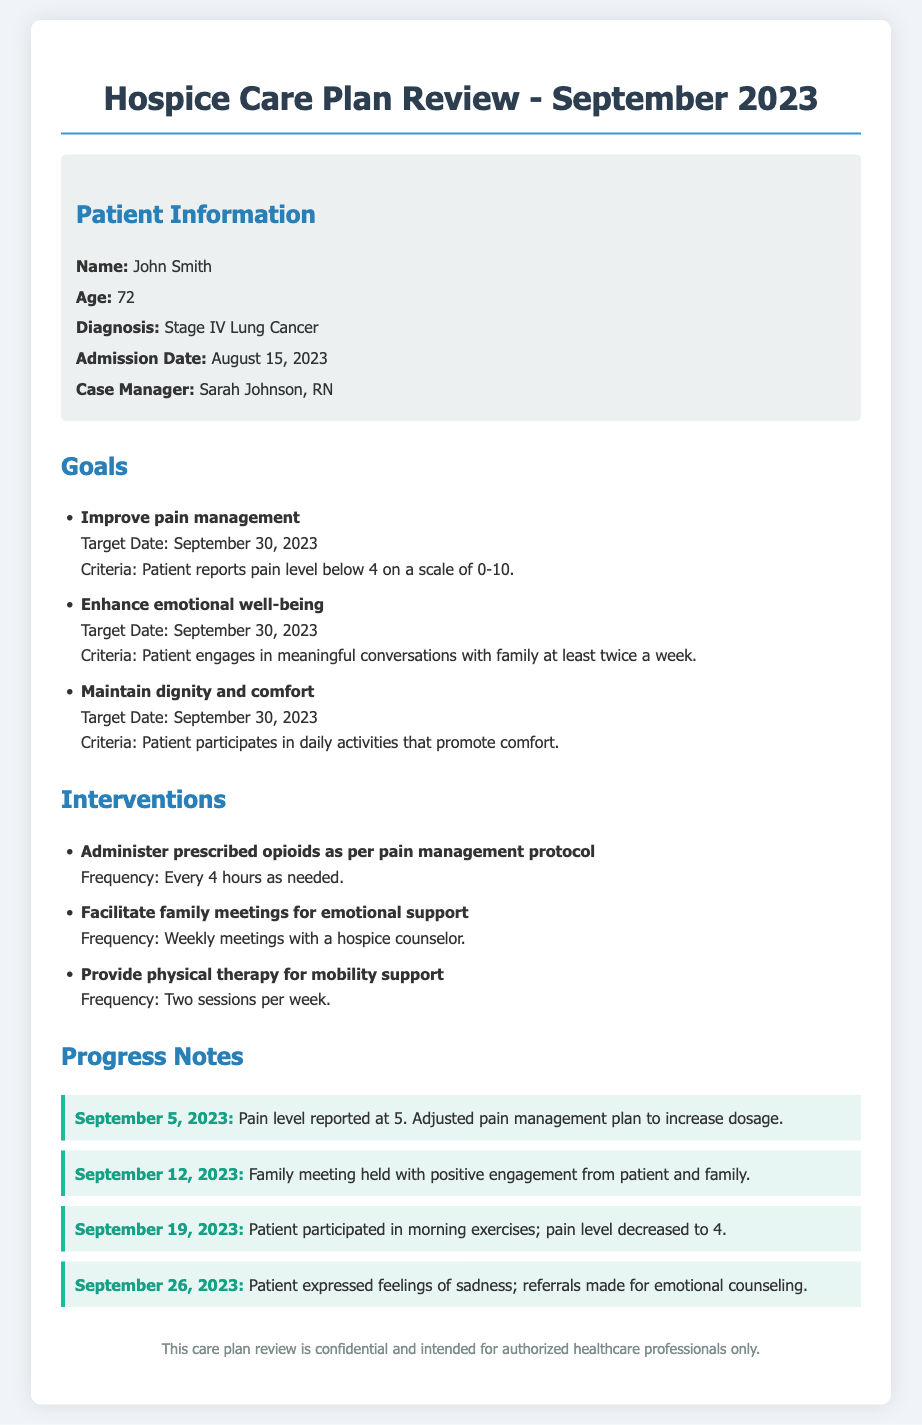What is the patient's name? The patient's name is explicitly mentioned in the document under Patient Information.
Answer: John Smith What is the diagnosis? The diagnosis is stated in the document, providing a specific medical condition.
Answer: Stage IV Lung Cancer What is the target date for the goals? The target date for all goals is listed in the Goals section of the document.
Answer: September 30, 2023 How frequently is physical therapy provided? The frequency of the intervention for physical therapy is stated under Interventions.
Answer: Two sessions per week What was the pain level reported on September 5, 2023? The pain level on that date is documented in the Progress Notes section.
Answer: 5 What intervention is used for emotional support? The document specifies the type of intervention aimed at providing emotional support.
Answer: Facilitate family meetings for emotional support What was the patient’s pain level after participating in morning exercises? This information is captured in the Progress Notes, relating to a specific date.
Answer: 4 What was the outcome of the family meeting on September 12, 2023? The outcome is summarized in the Progress Notes section regarding the engagement level.
Answer: Positive engagement from patient and family 